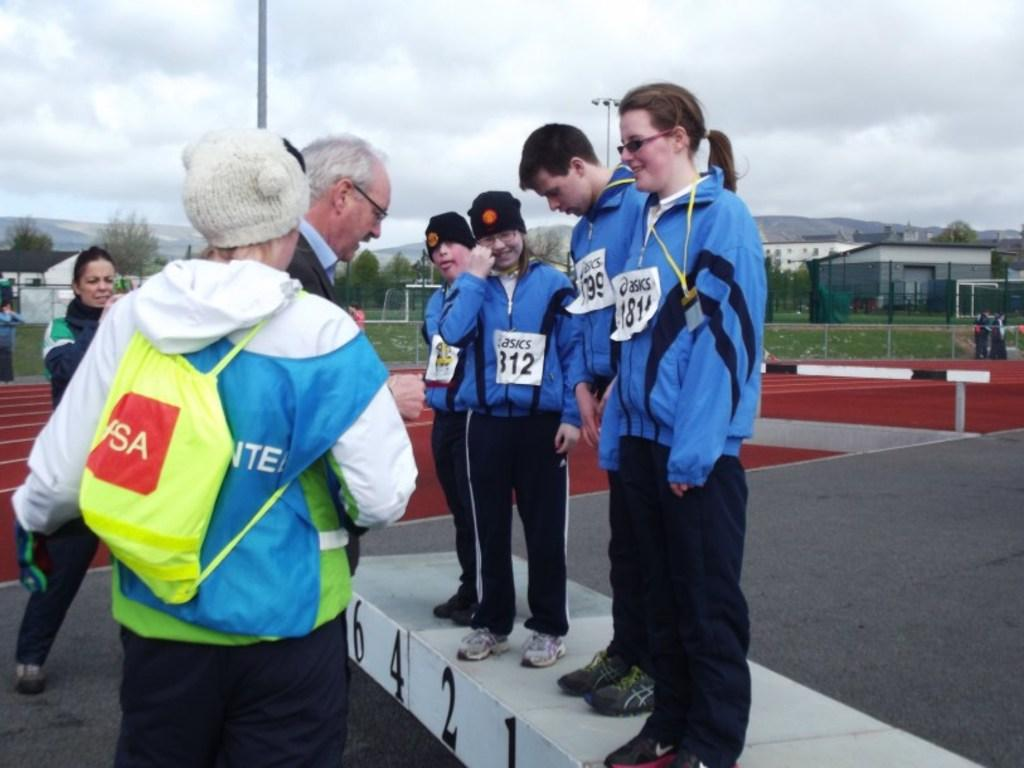<image>
Create a compact narrative representing the image presented. one of the sponsors of this event is asics 